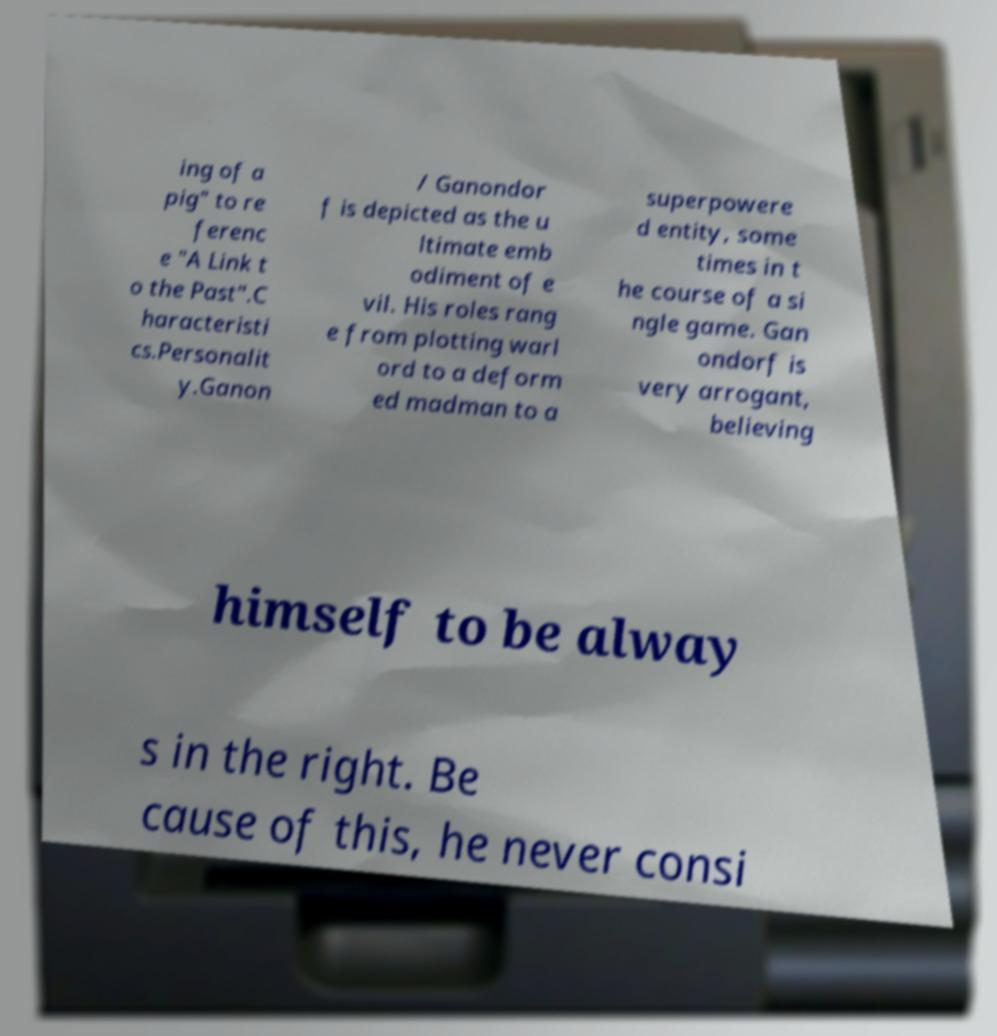Could you extract and type out the text from this image? ing of a pig" to re ferenc e "A Link t o the Past".C haracteristi cs.Personalit y.Ganon / Ganondor f is depicted as the u ltimate emb odiment of e vil. His roles rang e from plotting warl ord to a deform ed madman to a superpowere d entity, some times in t he course of a si ngle game. Gan ondorf is very arrogant, believing himself to be alway s in the right. Be cause of this, he never consi 